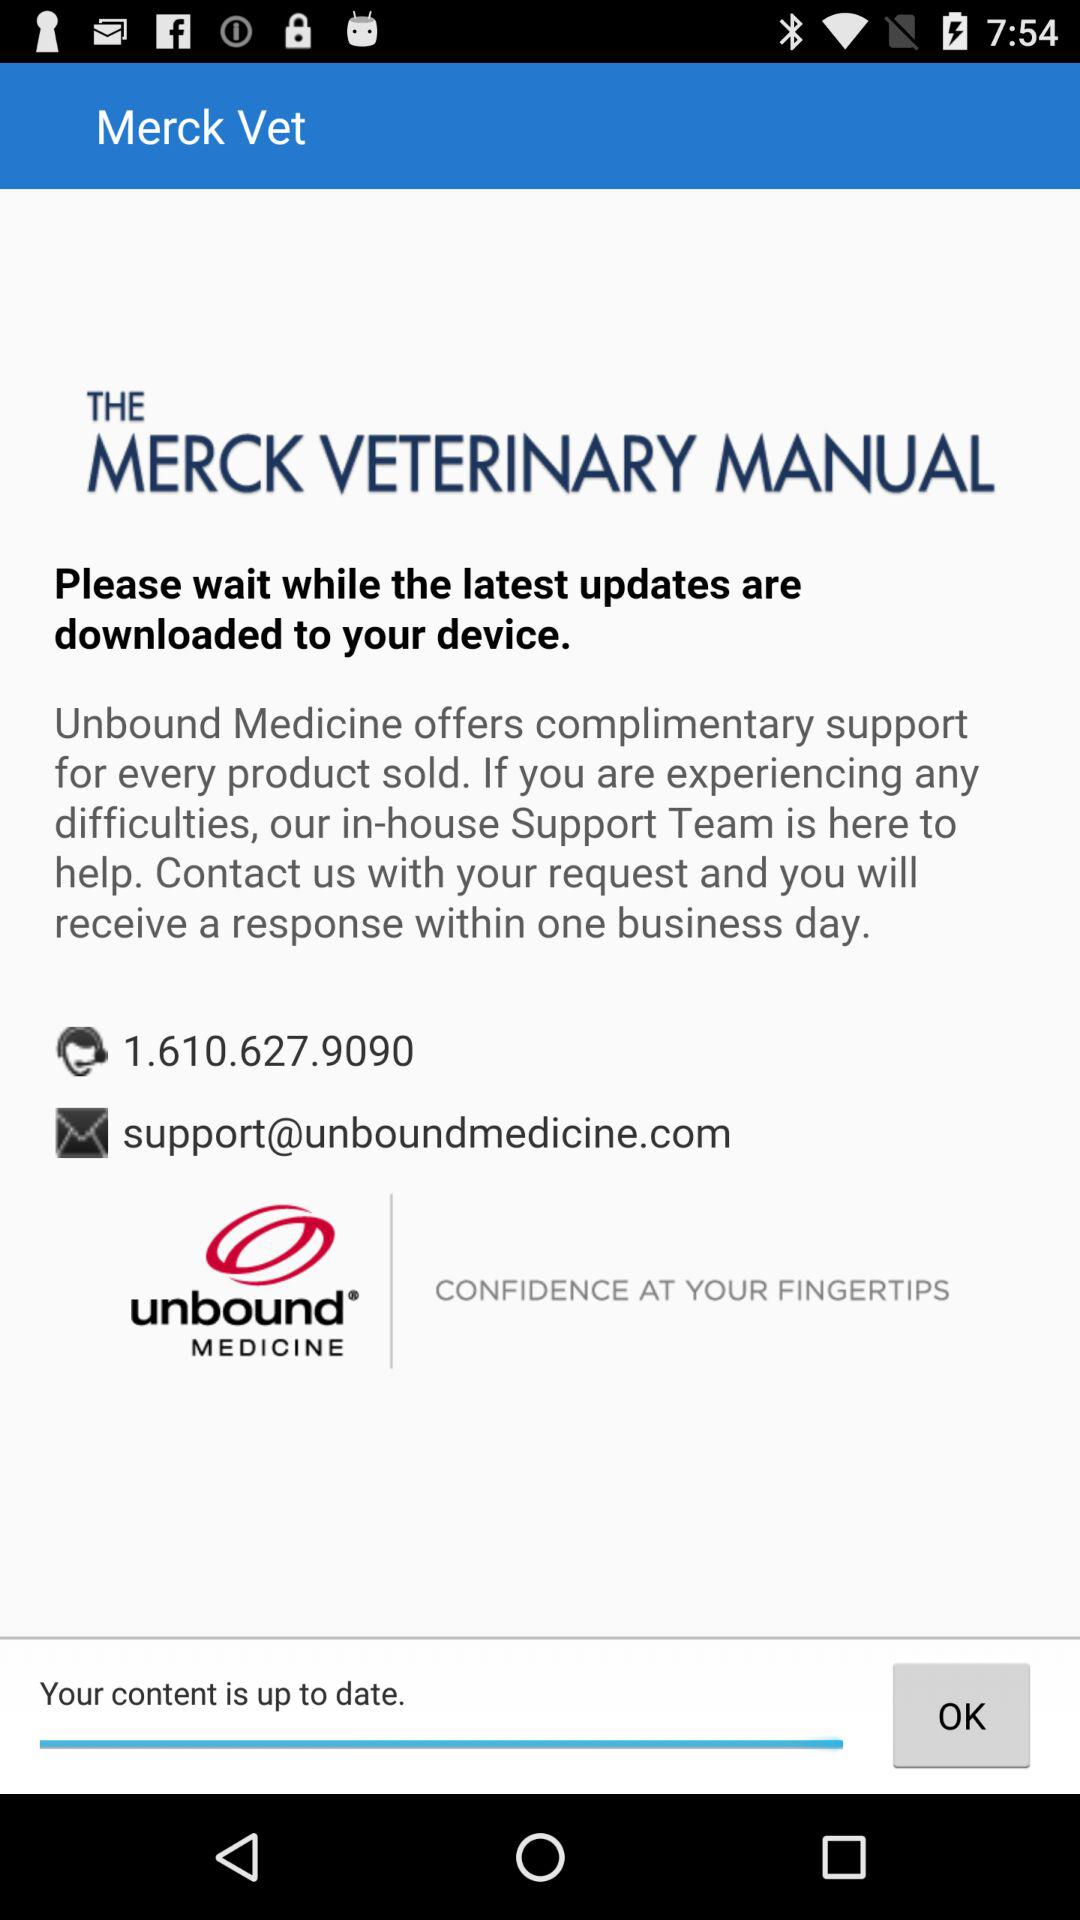What is the version?
When the provided information is insufficient, respond with <no answer>. <no answer> 